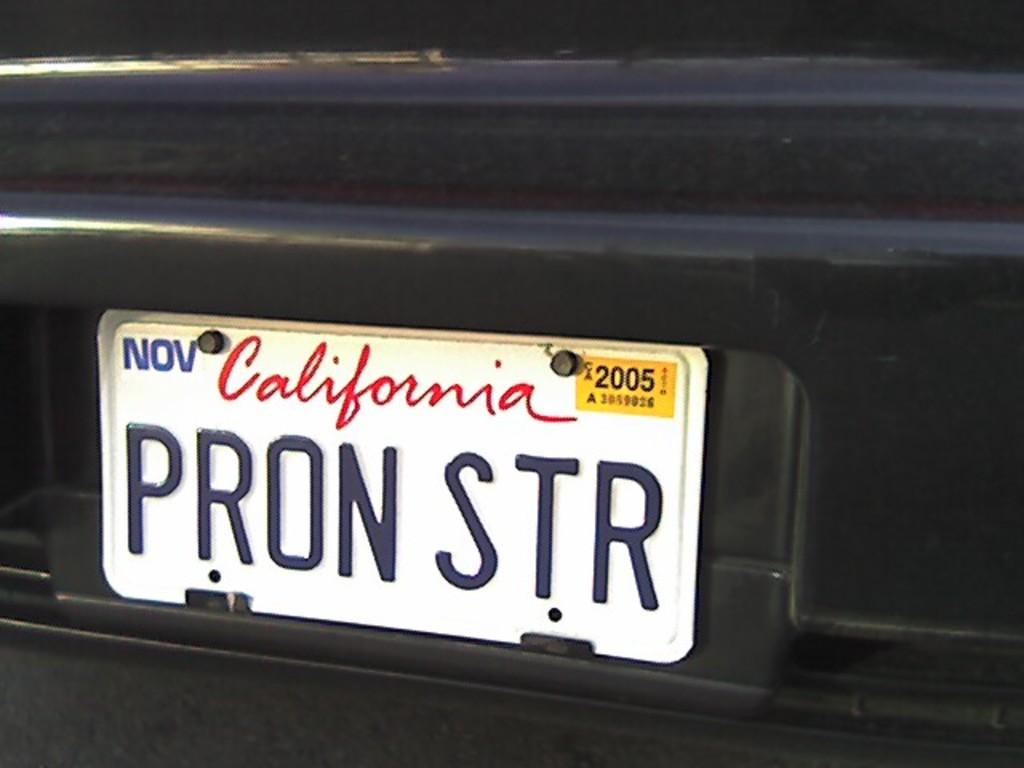What is the main subject of the image? The main subject of the image is a vehicle. Can you describe the color of the vehicle? The vehicle is black in color. Does the vehicle have any identifying features? Yes, the vehicle has a number plate. What is written on the number plate? The number plate has "California PRON STR" written on it. Can you hear the bell ringing in the image? There is no bell present in the image, so it cannot be heard. 